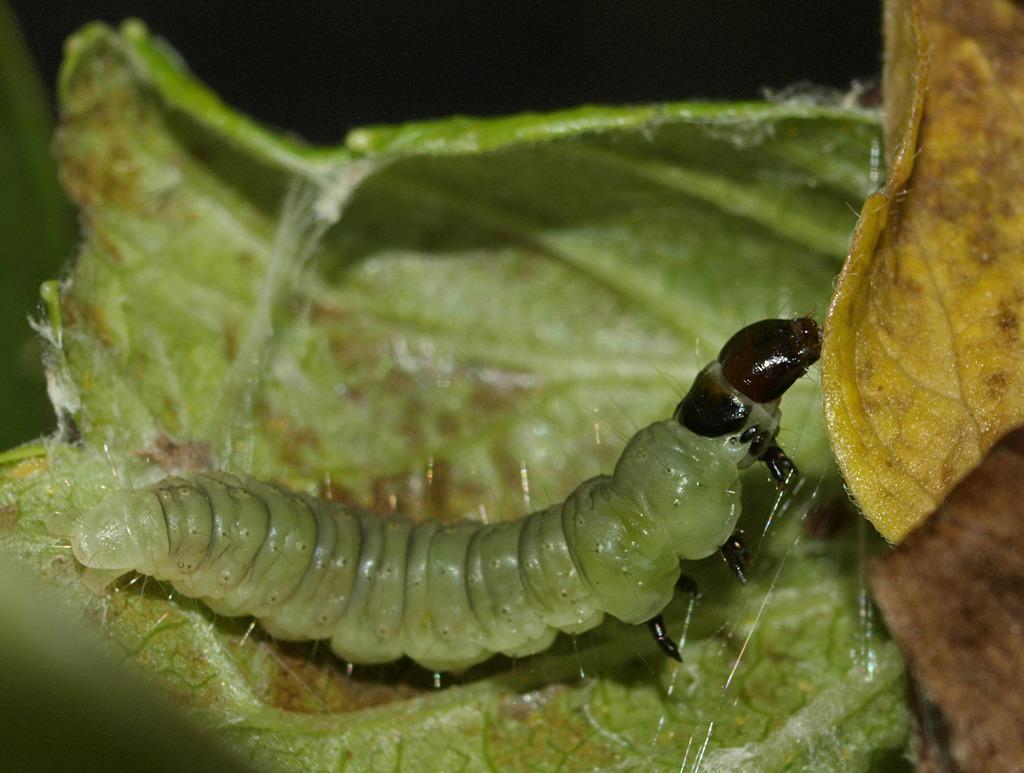Please provide a concise description of this image. In this image there are a few leaves. In the middle of the image there is a caterpillar on the leaf. 